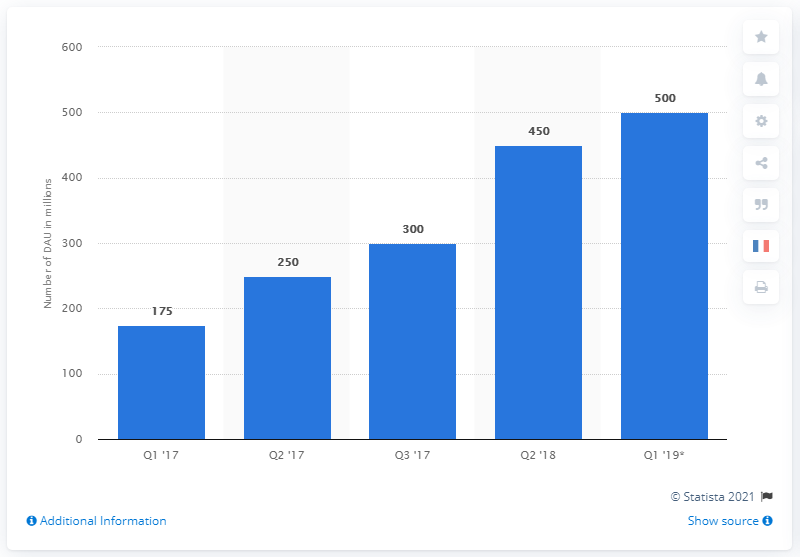Point out several critical features in this image. In the second quarter of 2018, there were 450 Status users. As of the latest reported period, WhatsApp had approximately 450 million daily active users worldwide. 